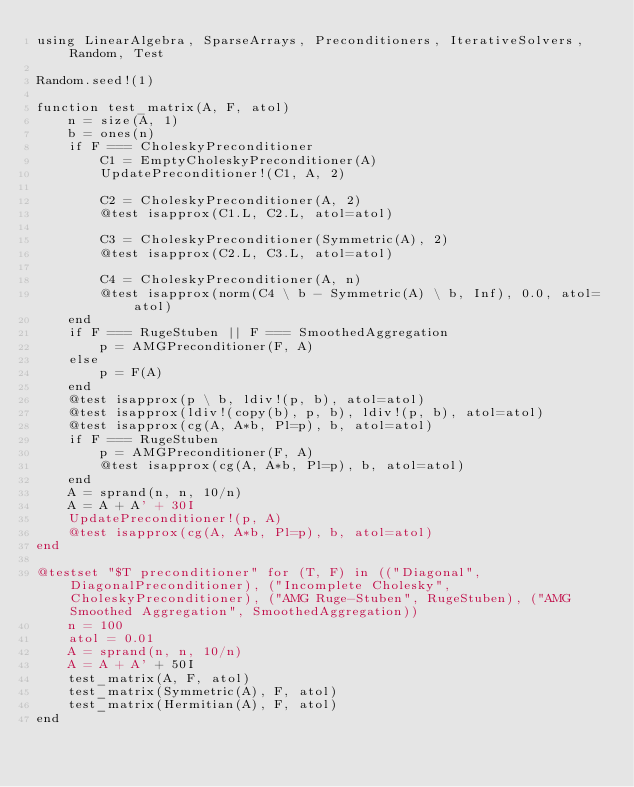<code> <loc_0><loc_0><loc_500><loc_500><_Julia_>using LinearAlgebra, SparseArrays, Preconditioners, IterativeSolvers, Random, Test

Random.seed!(1)

function test_matrix(A, F, atol)
    n = size(A, 1)
    b = ones(n)
    if F === CholeskyPreconditioner
        C1 = EmptyCholeskyPreconditioner(A)
        UpdatePreconditioner!(C1, A, 2)

        C2 = CholeskyPreconditioner(A, 2)
        @test isapprox(C1.L, C2.L, atol=atol)

        C3 = CholeskyPreconditioner(Symmetric(A), 2)
        @test isapprox(C2.L, C3.L, atol=atol)

        C4 = CholeskyPreconditioner(A, n)
        @test isapprox(norm(C4 \ b - Symmetric(A) \ b, Inf), 0.0, atol=atol)
    end
    if F === RugeStuben || F === SmoothedAggregation
        p = AMGPreconditioner(F, A)
    else
        p = F(A)
    end
    @test isapprox(p \ b, ldiv!(p, b), atol=atol)
    @test isapprox(ldiv!(copy(b), p, b), ldiv!(p, b), atol=atol)
    @test isapprox(cg(A, A*b, Pl=p), b, atol=atol)
    if F === RugeStuben
        p = AMGPreconditioner(F, A)
        @test isapprox(cg(A, A*b, Pl=p), b, atol=atol)
    end
    A = sprand(n, n, 10/n)
    A = A + A' + 30I
    UpdatePreconditioner!(p, A)
    @test isapprox(cg(A, A*b, Pl=p), b, atol=atol)
end

@testset "$T preconditioner" for (T, F) in (("Diagonal", DiagonalPreconditioner), ("Incomplete Cholesky", CholeskyPreconditioner), ("AMG Ruge-Stuben", RugeStuben), ("AMG Smoothed Aggregation", SmoothedAggregation))
    n = 100
    atol = 0.01
    A = sprand(n, n, 10/n)
    A = A + A' + 50I
    test_matrix(A, F, atol)
    test_matrix(Symmetric(A), F, atol)
    test_matrix(Hermitian(A), F, atol)
end
</code> 